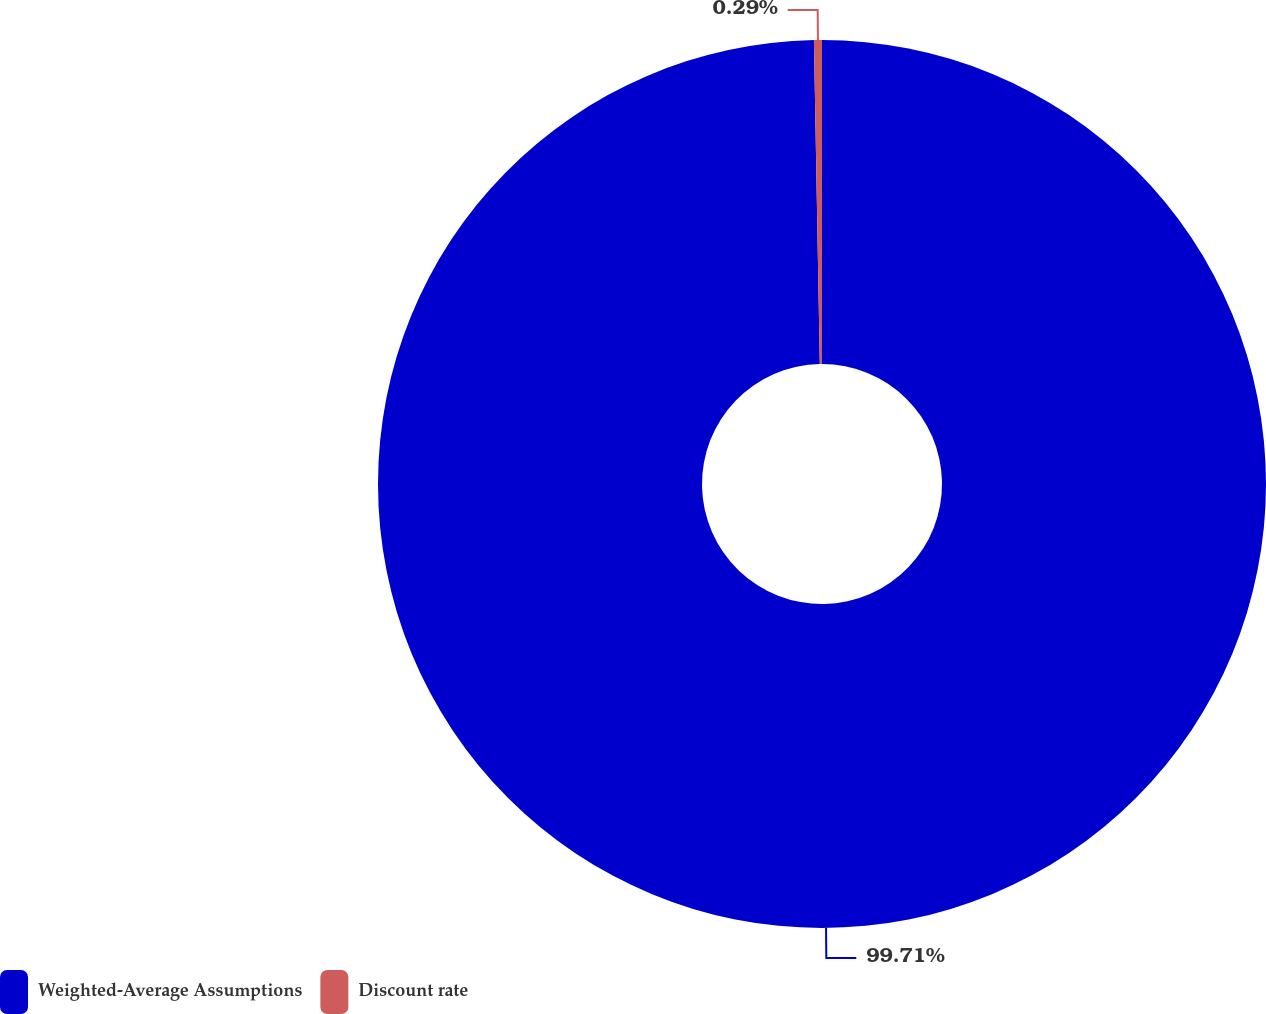Convert chart. <chart><loc_0><loc_0><loc_500><loc_500><pie_chart><fcel>Weighted-Average Assumptions<fcel>Discount rate<nl><fcel>99.71%<fcel>0.29%<nl></chart> 